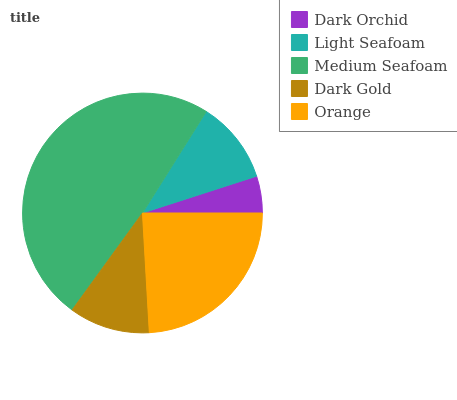Is Dark Orchid the minimum?
Answer yes or no. Yes. Is Medium Seafoam the maximum?
Answer yes or no. Yes. Is Light Seafoam the minimum?
Answer yes or no. No. Is Light Seafoam the maximum?
Answer yes or no. No. Is Light Seafoam greater than Dark Orchid?
Answer yes or no. Yes. Is Dark Orchid less than Light Seafoam?
Answer yes or no. Yes. Is Dark Orchid greater than Light Seafoam?
Answer yes or no. No. Is Light Seafoam less than Dark Orchid?
Answer yes or no. No. Is Light Seafoam the high median?
Answer yes or no. Yes. Is Light Seafoam the low median?
Answer yes or no. Yes. Is Dark Gold the high median?
Answer yes or no. No. Is Dark Gold the low median?
Answer yes or no. No. 